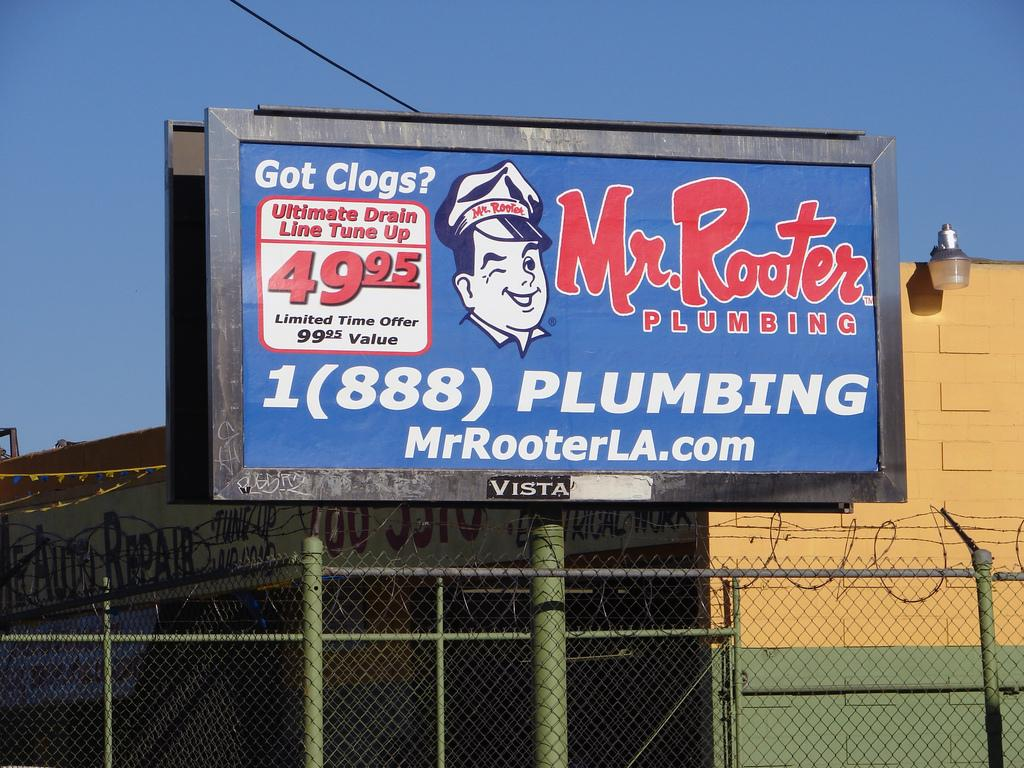Provide a one-sentence caption for the provided image. A banner with Mr. Rooter plumbing information wrote on it. 